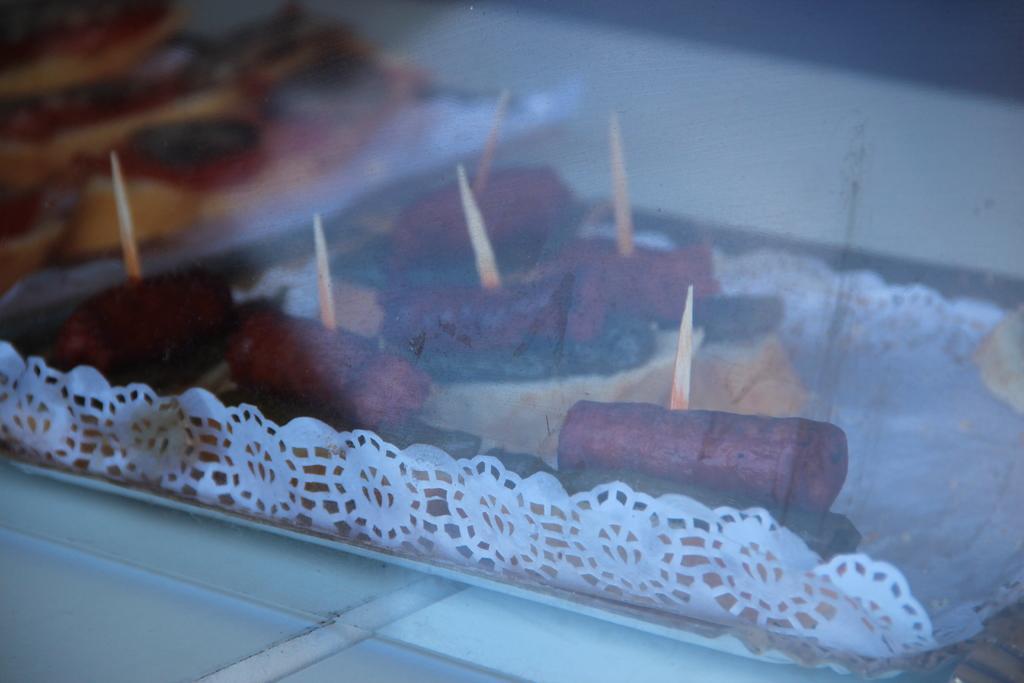Could you give a brief overview of what you see in this image? In this picture, it looks like a transparent glass and behind the glass there are some food items on the paper. Behind the food items there is the blurred background. 